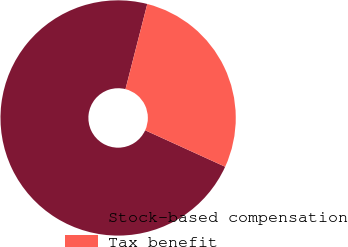Convert chart to OTSL. <chart><loc_0><loc_0><loc_500><loc_500><pie_chart><fcel>Stock-based compensation<fcel>Tax benefit<nl><fcel>72.18%<fcel>27.82%<nl></chart> 